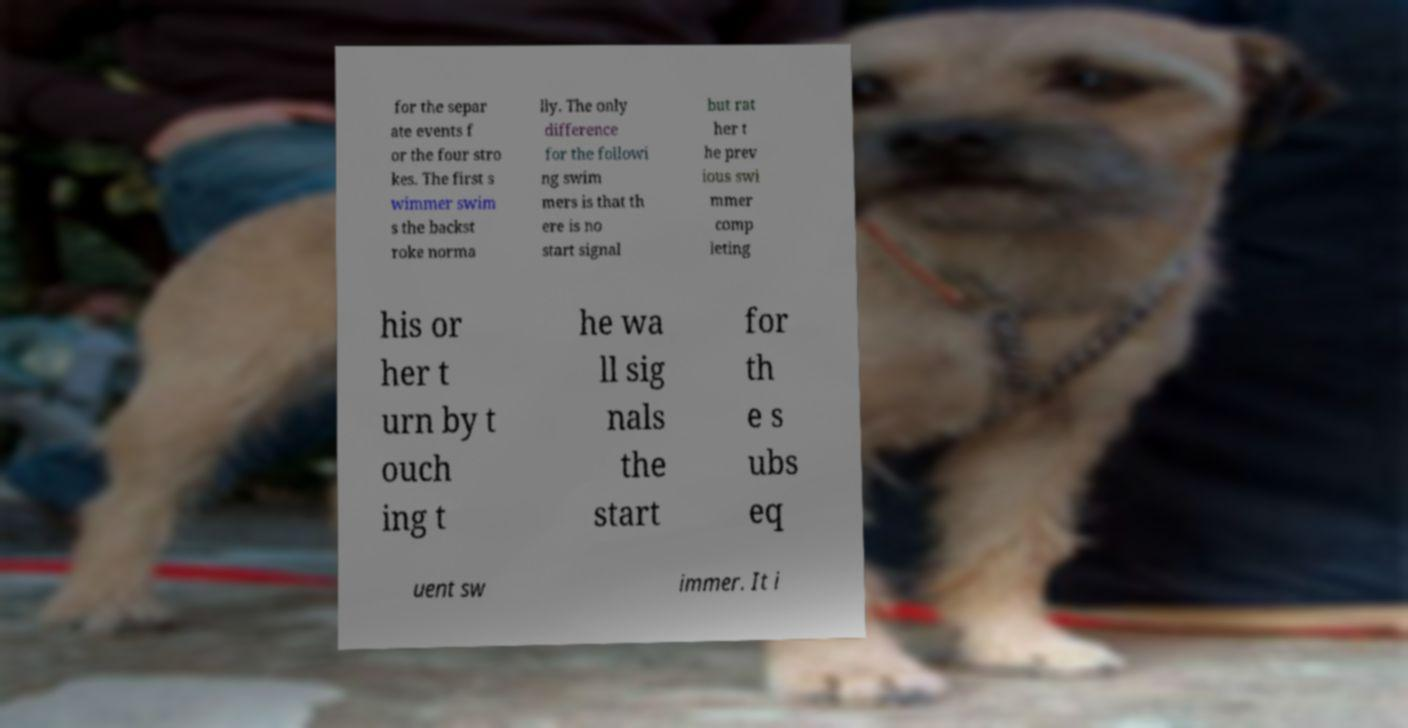Please read and relay the text visible in this image. What does it say? for the separ ate events f or the four stro kes. The first s wimmer swim s the backst roke norma lly. The only difference for the followi ng swim mers is that th ere is no start signal but rat her t he prev ious swi mmer comp leting his or her t urn by t ouch ing t he wa ll sig nals the start for th e s ubs eq uent sw immer. It i 